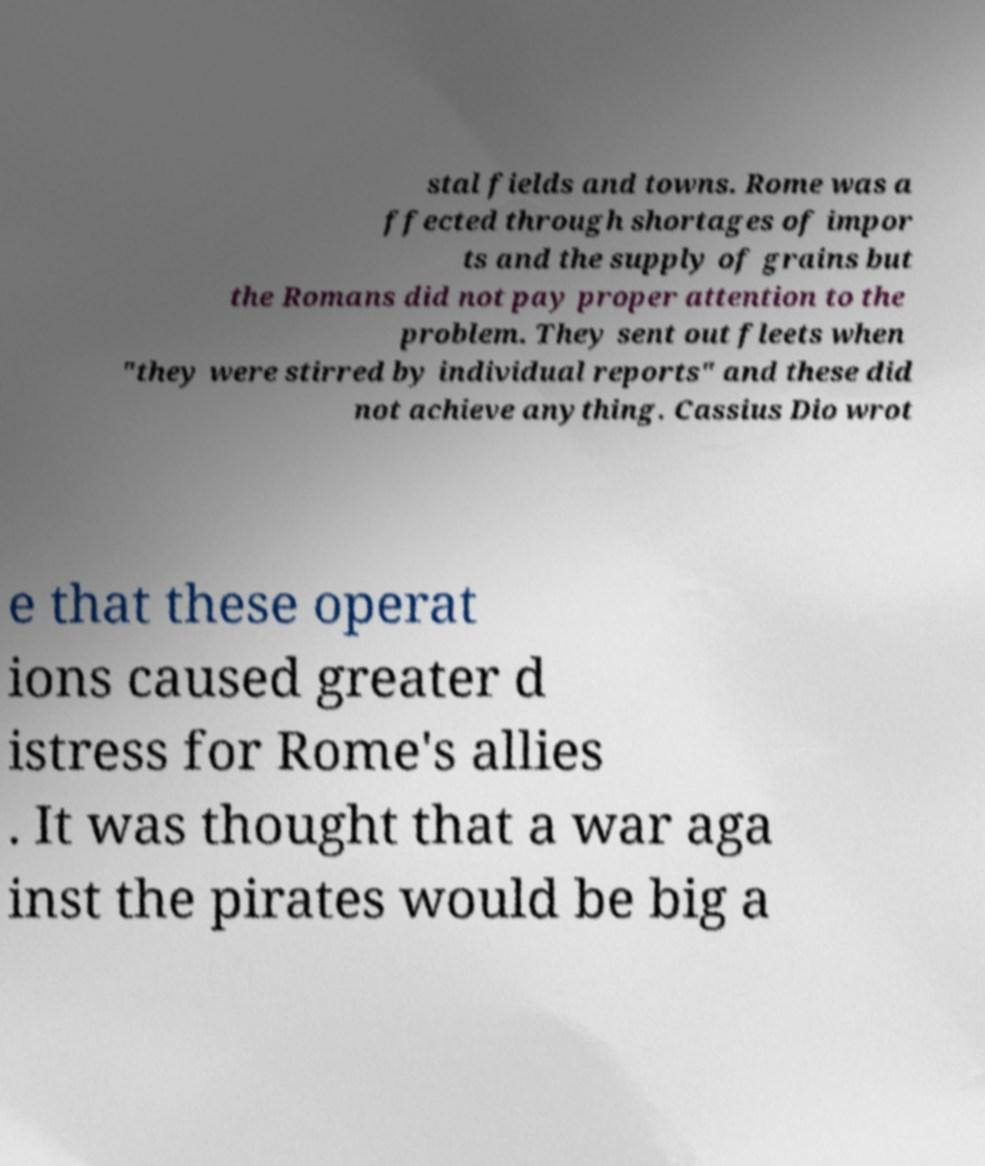Please identify and transcribe the text found in this image. stal fields and towns. Rome was a ffected through shortages of impor ts and the supply of grains but the Romans did not pay proper attention to the problem. They sent out fleets when "they were stirred by individual reports" and these did not achieve anything. Cassius Dio wrot e that these operat ions caused greater d istress for Rome's allies . It was thought that a war aga inst the pirates would be big a 